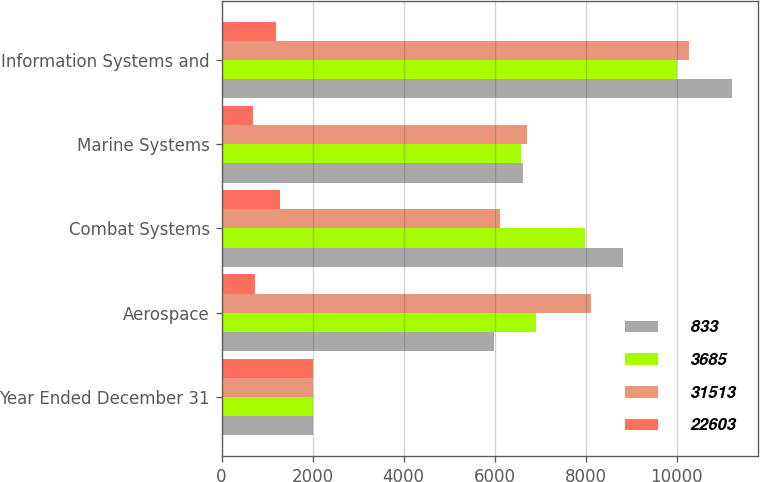Convert chart. <chart><loc_0><loc_0><loc_500><loc_500><stacked_bar_chart><ecel><fcel>Year Ended December 31<fcel>Aerospace<fcel>Combat Systems<fcel>Marine Systems<fcel>Information Systems and<nl><fcel>833<fcel>2011<fcel>5998<fcel>8827<fcel>6631<fcel>11221<nl><fcel>3685<fcel>2012<fcel>6912<fcel>7992<fcel>6592<fcel>10017<nl><fcel>31513<fcel>2013<fcel>8118<fcel>6120<fcel>6712<fcel>10268<nl><fcel>22603<fcel>2011<fcel>729<fcel>1283<fcel>691<fcel>1200<nl></chart> 